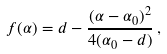Convert formula to latex. <formula><loc_0><loc_0><loc_500><loc_500>f ( \alpha ) = d - \frac { ( \alpha - \alpha _ { 0 } ) ^ { 2 } } { 4 ( \alpha _ { 0 } - d ) } \, ,</formula> 